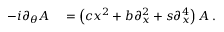<formula> <loc_0><loc_0><loc_500><loc_500>\begin{array} { r l } { - i \partial _ { \theta } A } & = \left ( c x ^ { 2 } + b \partial _ { x } ^ { 2 } + s \partial _ { x } ^ { 4 } \right ) A \, . } \end{array}</formula> 